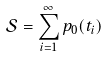<formula> <loc_0><loc_0><loc_500><loc_500>\mathcal { S } = \sum _ { i = 1 } ^ { \infty } p _ { 0 } ( t _ { i } )</formula> 